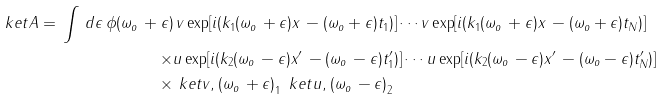<formula> <loc_0><loc_0><loc_500><loc_500>\ k e t { A } = \, \int \, d \epsilon \, \phi ( \omega _ { o } \, + \epsilon ) & \, v \exp [ i ( k _ { 1 } ( \omega _ { o } \, + \epsilon ) x \, - ( \omega _ { o } + \epsilon ) t _ { 1 } ) ] \cdots v \exp [ i ( k _ { 1 } ( \omega _ { o } \, + \epsilon ) x \, - ( \omega _ { o } + \epsilon ) t _ { N } ) ] \\ \times & u \exp [ i ( k _ { 2 } ( \omega _ { o } \, - \epsilon ) x ^ { \prime } \, - ( \omega _ { o } \, - \epsilon ) t _ { 1 } ^ { \prime } ) ] \cdots u \exp [ i ( k _ { 2 } ( \omega _ { o } \, - \epsilon ) x ^ { \prime } \, - ( \omega _ { o } - \epsilon ) t _ { N } ^ { \prime } ) ] \\ \times & \ k e t { v , ( \omega _ { o } \, + \epsilon ) } _ { 1 } \, \ k e t { u , ( \omega _ { o } \, - \epsilon ) } _ { 2 } \\</formula> 